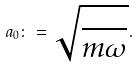<formula> <loc_0><loc_0><loc_500><loc_500>a _ { 0 } \colon = \sqrt { \frac { } { m \omega } } .</formula> 